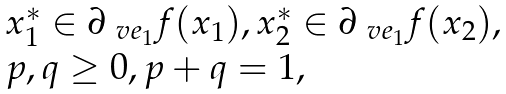<formula> <loc_0><loc_0><loc_500><loc_500>\begin{array} { l } x _ { 1 } ^ { * } \in \partial _ { \ v e _ { 1 } } f ( x _ { 1 } ) , x _ { 2 } ^ { * } \in \partial _ { \ v e _ { 1 } } f ( x _ { 2 } ) , \\ p , q \geq 0 , p + q = 1 , \end{array}</formula> 